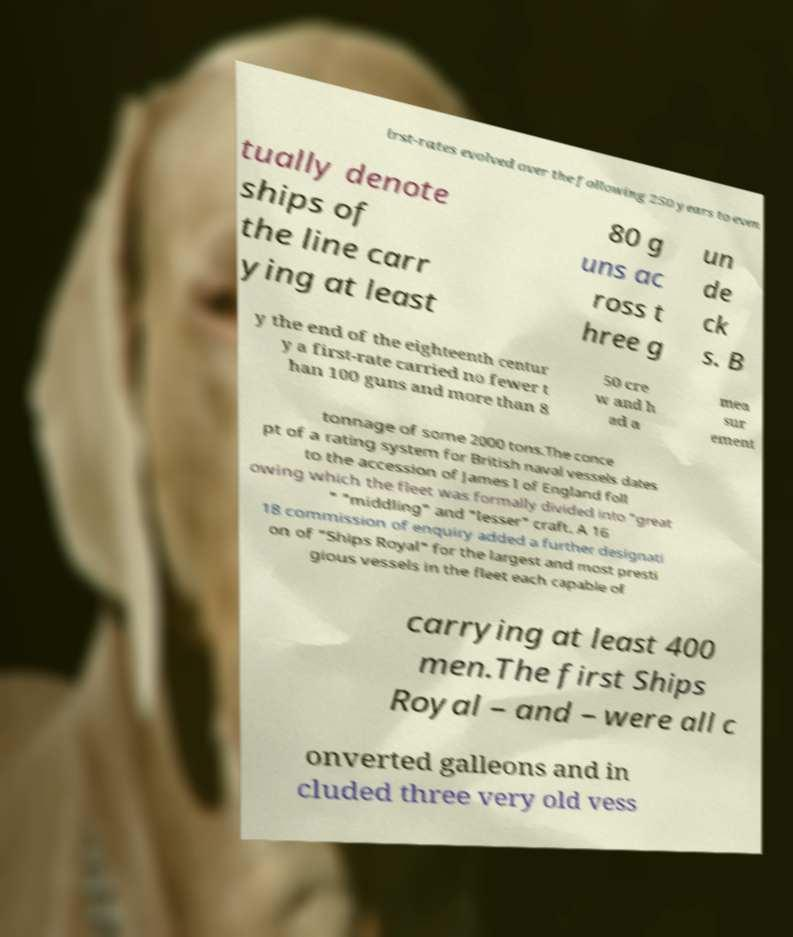For documentation purposes, I need the text within this image transcribed. Could you provide that? irst-rates evolved over the following 250 years to even tually denote ships of the line carr ying at least 80 g uns ac ross t hree g un de ck s. B y the end of the eighteenth centur y a first-rate carried no fewer t han 100 guns and more than 8 50 cre w and h ad a mea sur ement tonnage of some 2000 tons.The conce pt of a rating system for British naval vessels dates to the accession of James I of England foll owing which the fleet was formally divided into "great " "middling" and "lesser" craft. A 16 18 commission of enquiry added a further designati on of "Ships Royal" for the largest and most presti gious vessels in the fleet each capable of carrying at least 400 men.The first Ships Royal – and – were all c onverted galleons and in cluded three very old vess 